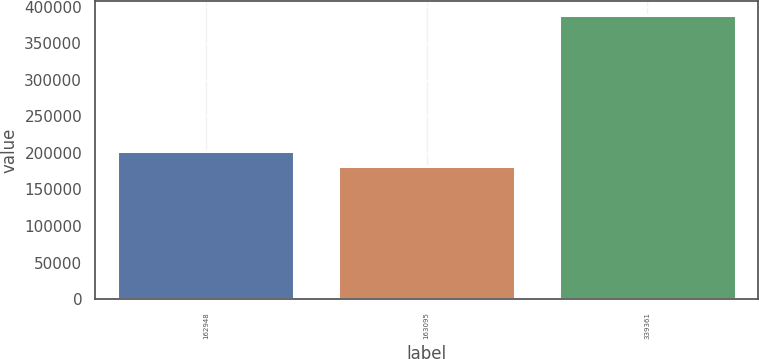<chart> <loc_0><loc_0><loc_500><loc_500><bar_chart><fcel>162948<fcel>163095<fcel>339361<nl><fcel>202737<fcel>182116<fcel>388324<nl></chart> 